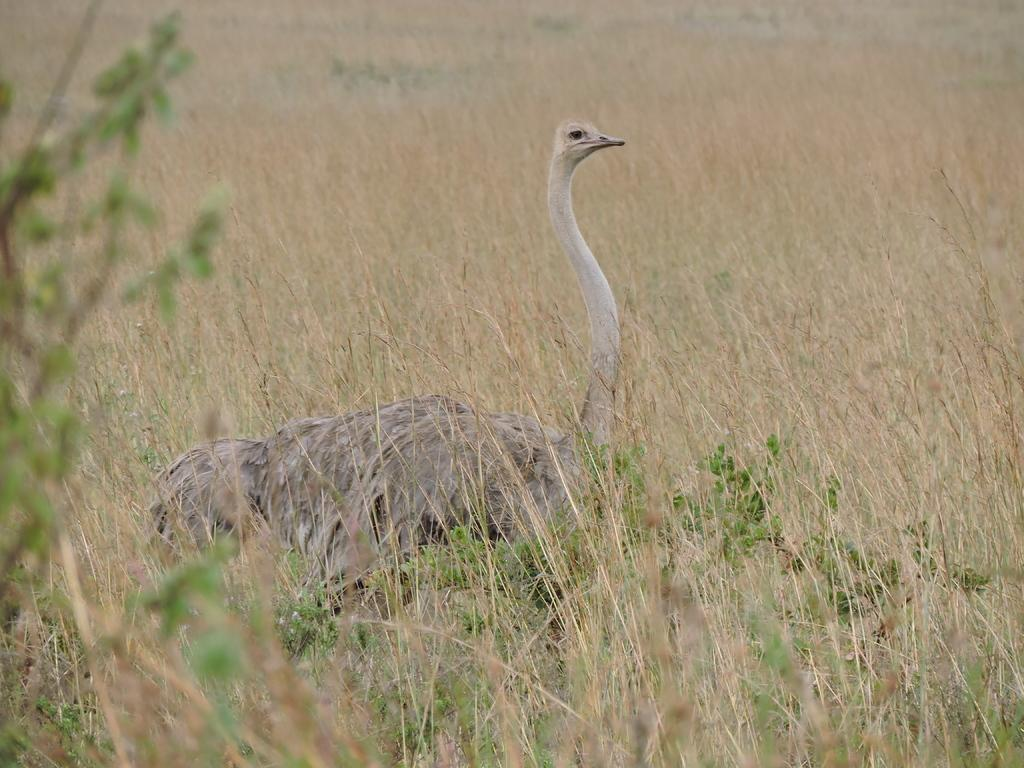What animal is the main subject of the image? There is an ostrich in the image. What is the ostrich standing on? The ostrich is standing on the grass. Is there any smoke coming from the ostrich's beak in the image? No, there is no smoke coming from the ostrich's beak in the image. How many baby ostriches can be seen in the image? There are no baby ostriches present in the image; only one ostrich is visible. 